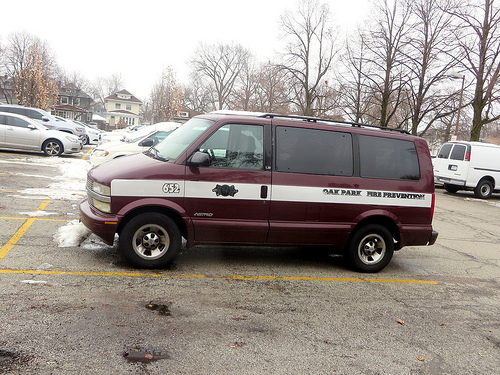<image>
Is the tire next to the house? No. The tire is not positioned next to the house. They are located in different areas of the scene. Is there a van in the ice? No. The van is not contained within the ice. These objects have a different spatial relationship. 